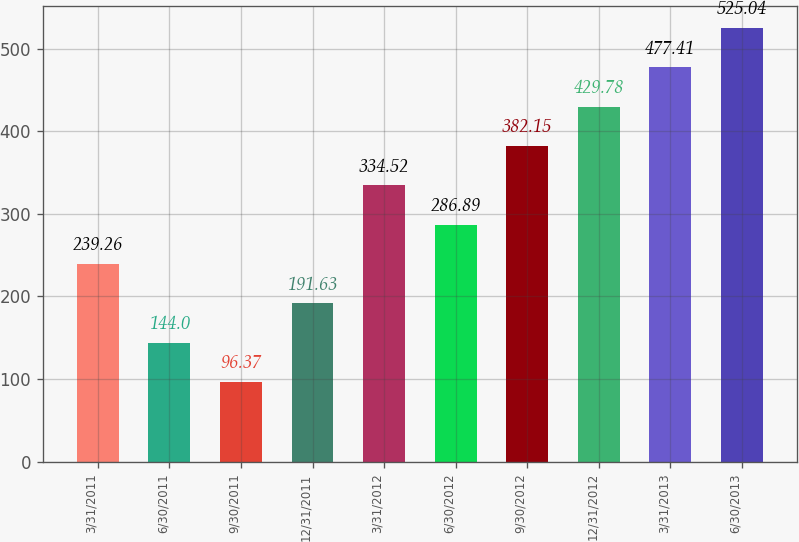Convert chart to OTSL. <chart><loc_0><loc_0><loc_500><loc_500><bar_chart><fcel>3/31/2011<fcel>6/30/2011<fcel>9/30/2011<fcel>12/31/2011<fcel>3/31/2012<fcel>6/30/2012<fcel>9/30/2012<fcel>12/31/2012<fcel>3/31/2013<fcel>6/30/2013<nl><fcel>239.26<fcel>144<fcel>96.37<fcel>191.63<fcel>334.52<fcel>286.89<fcel>382.15<fcel>429.78<fcel>477.41<fcel>525.04<nl></chart> 